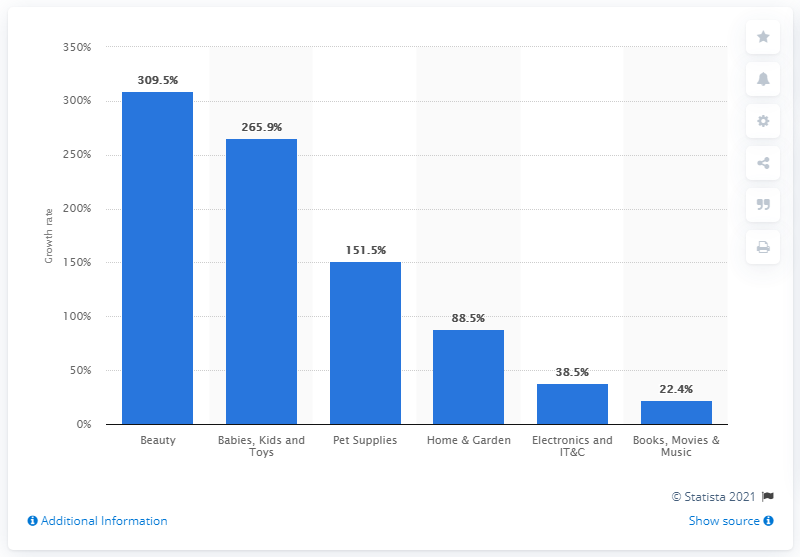Highlight a few significant elements in this photo. According to the data, the growth in the beauty sector in April 2020 was 309.5%. During the COVID-19 pandemic, there was a significant growth in online sales of books, movies, and music. Specifically, online sales of these items increased by 22.4%. 